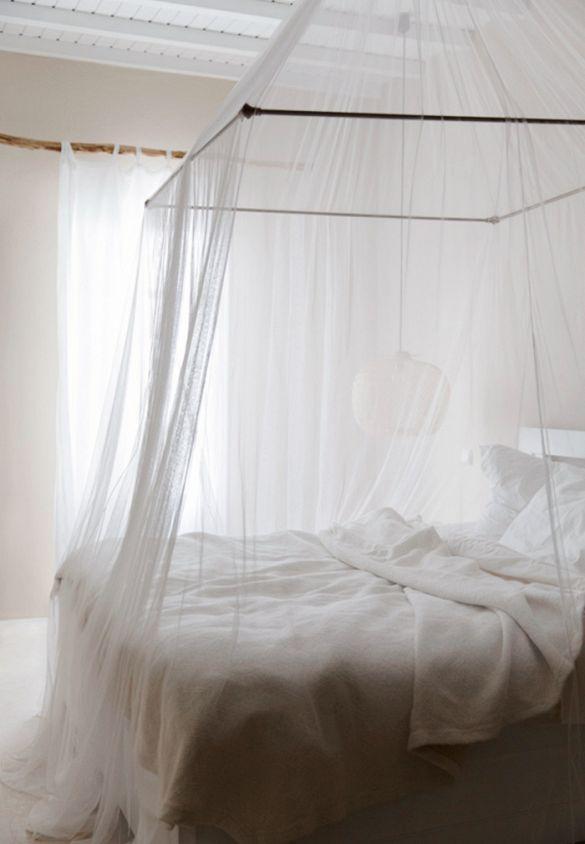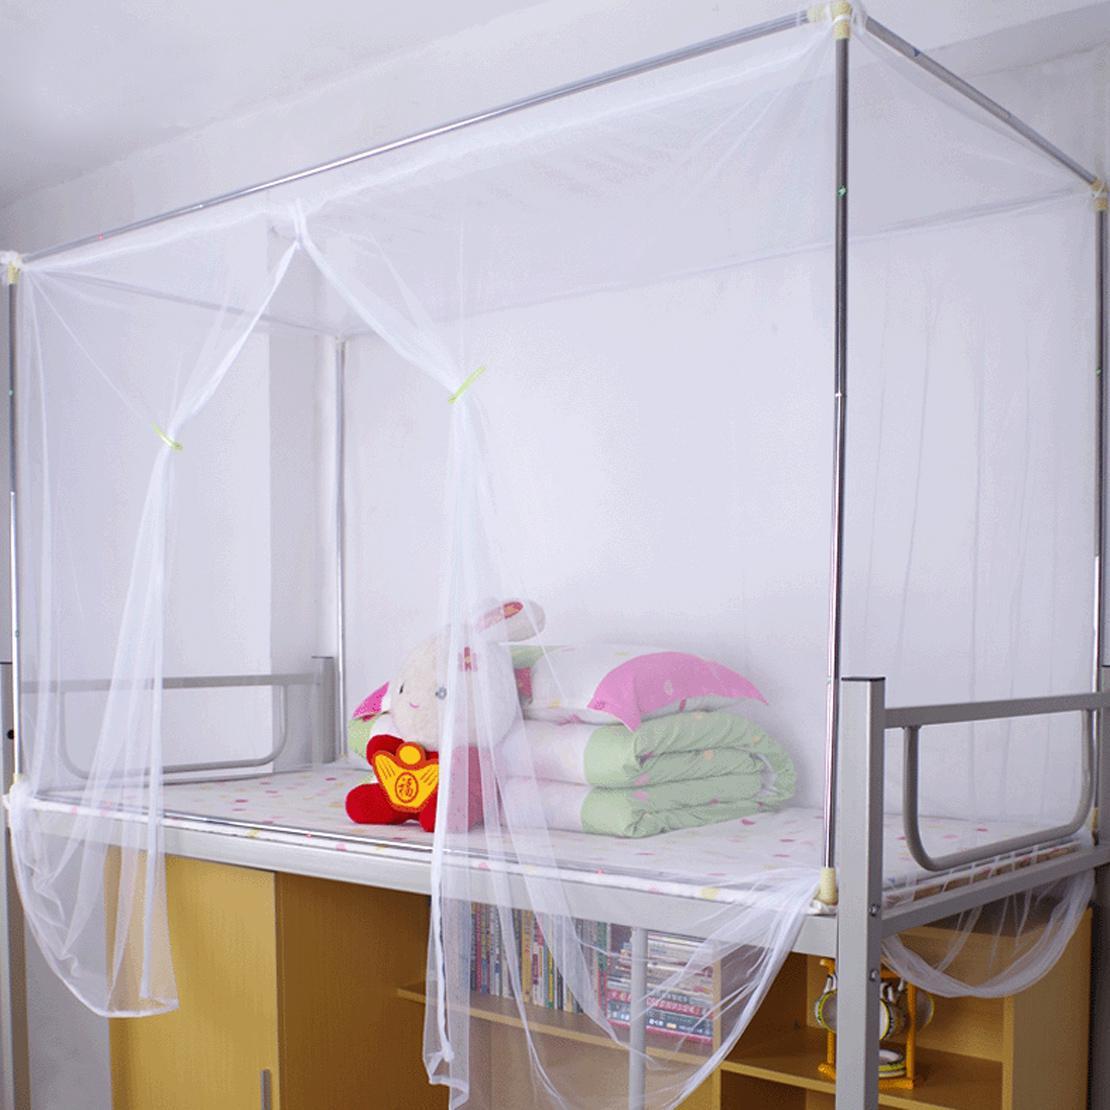The first image is the image on the left, the second image is the image on the right. Examine the images to the left and right. Is the description "Each image shows a gauzy white canopy that drapes from a cone shape suspended from the ceiling, but only the left image shows a canopy over a bed." accurate? Answer yes or no. No. The first image is the image on the left, the second image is the image on the right. Analyze the images presented: Is the assertion "There is at least one window behind the canopy in one of the images" valid? Answer yes or no. Yes. 